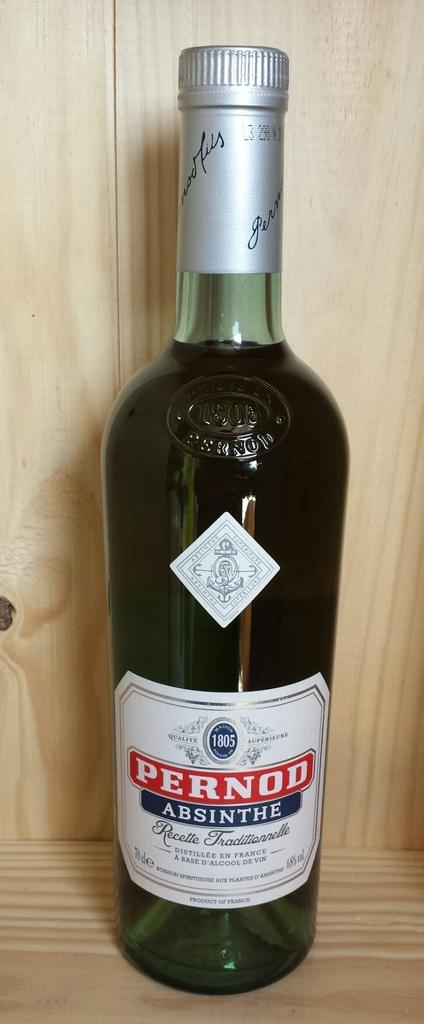<image>
Share a concise interpretation of the image provided. a bottle of Pernod Absinthe Recette Traditionnelle sits on a wood shelf 